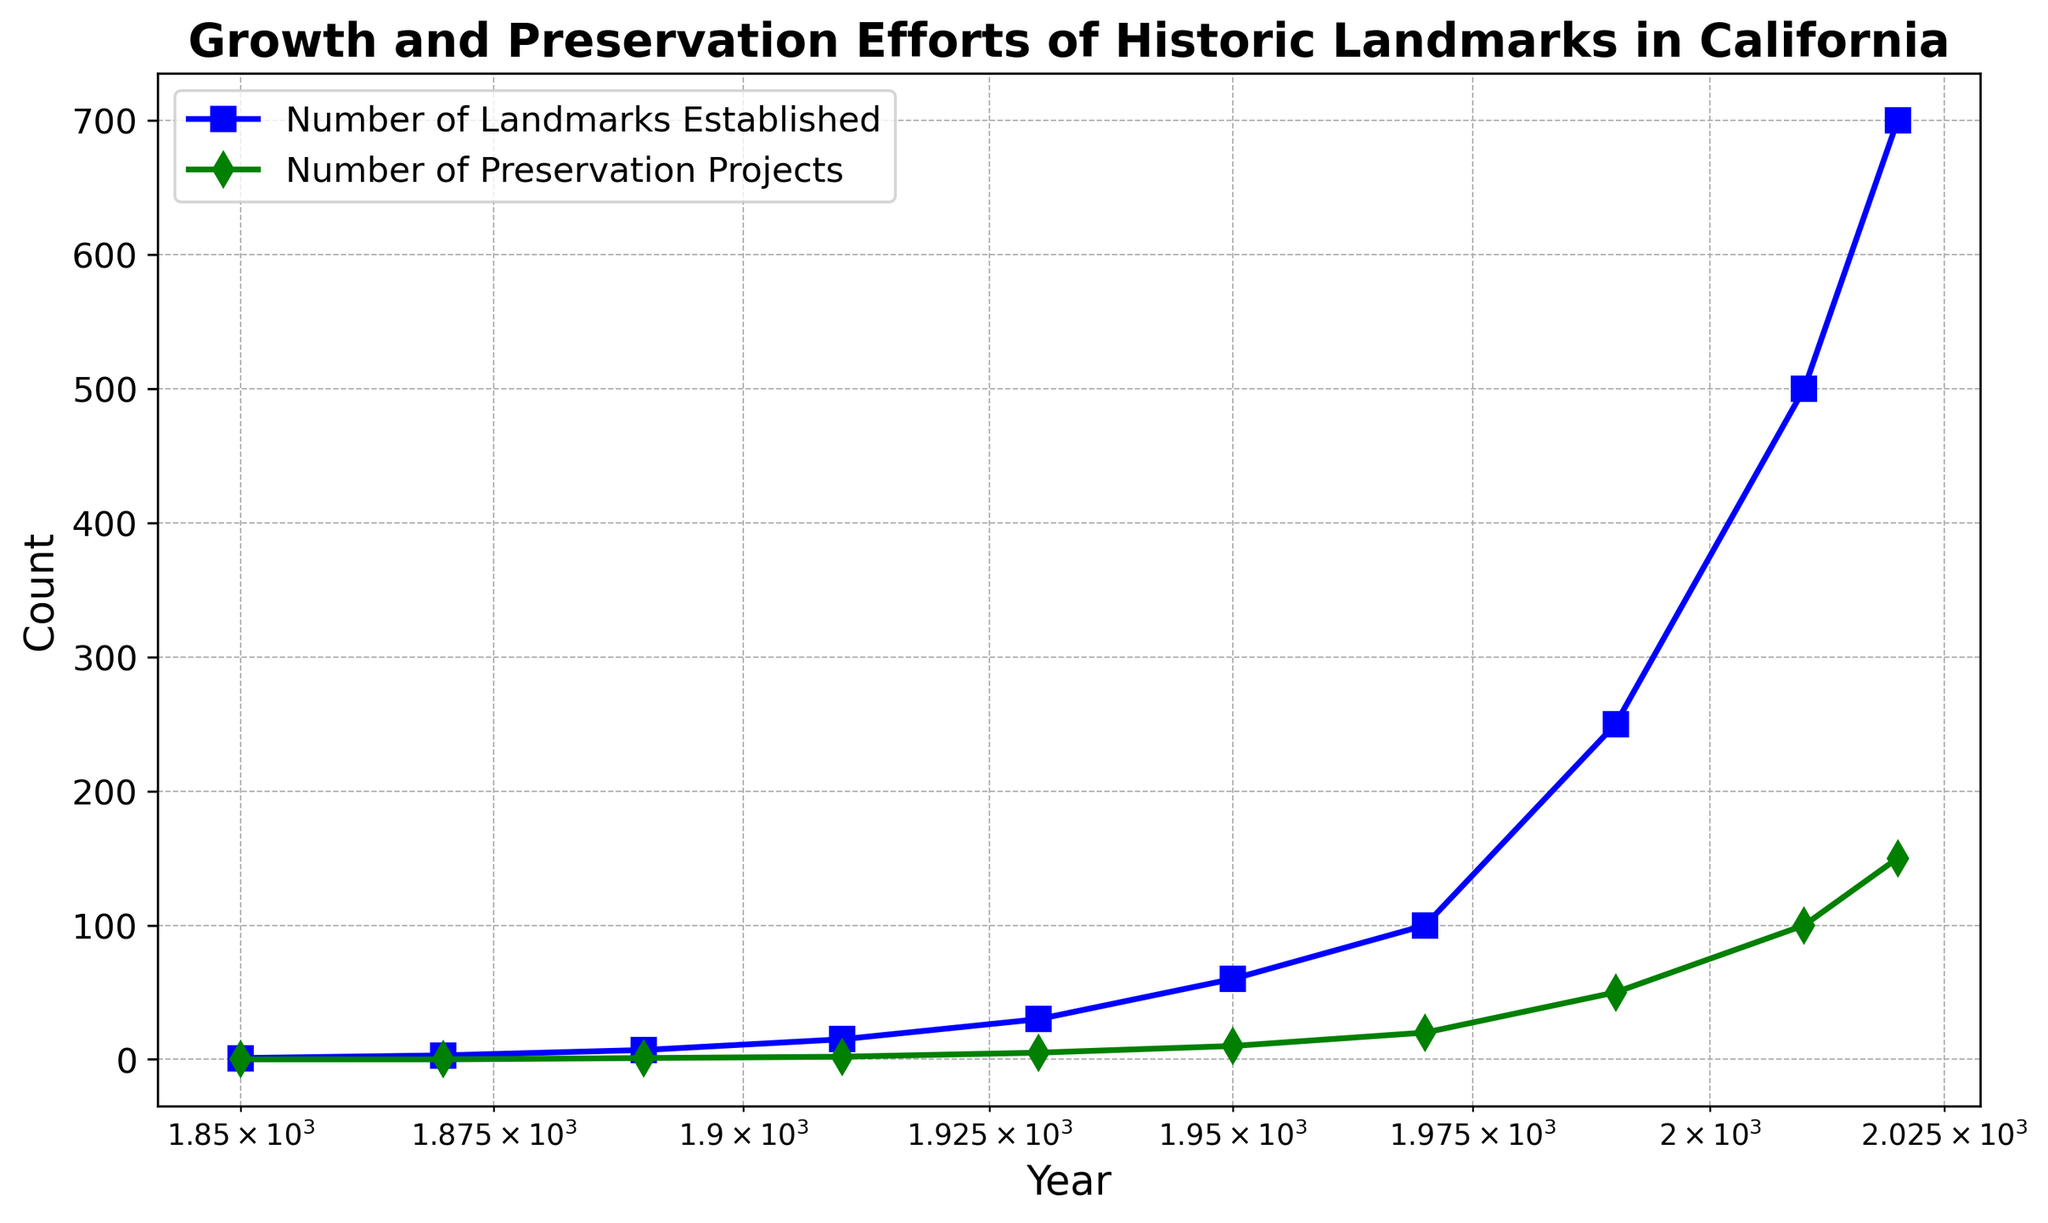What is the overall trend in the number of landmarks established from 1850 to 2020? The plot shows a consistent upward trend in the number of landmarks established over time, with a significant increase starting around 1930. By 2020, the number has reached 700.
Answer: Upward trend How many landmarks were established in 1970, and how many preservation projects were undertaken in the same year? The plot shows that in 1970, there were 100 landmarks established and 20 preservation projects undertaken.
Answer: 100 landmarks, 20 preservation projects How has the number of preservation projects changed from 1890 to 2020? The plot indicates a steady increase in preservation projects, starting from 1 project in 1890 to 150 projects in 2020.
Answer: Steady increase By how much did the number of preservation projects exceed the number of landmarks established in 2020? In 2020, there were 700 landmarks established and 150 preservation projects. The preservation projects did not exceed the landmarks, rather there were 550 fewer preservation projects compared to the landmarks.
Answer: 550 fewer Between which decades was the steepest growth in the number of landmarks established observed? The steepest growth appears to be between 1970 and 1990 where the number of landmarks increased from 100 to 250.
Answer: 1970 to 1990 Compare the number of landmarks established and preservation projects in 1950. Which was higher and by how much? In 1950, there were 60 landmarks established and 10 preservation projects. The number of landmarks established was higher by 50.
Answer: Landmarks higher by 50 What was the approximate ratio of preservation projects to landmarks established in 2010? In 2010, there were 500 landmarks established and 100 preservation projects. The ratio of preservation projects to landmarks established is 100/500 or 1:5.
Answer: 1:5 Which period saw a doubling in the number of landmarks established from approximately 250 to 500? The doubling in the number of landmarks from 250 to 500 occurred between 1990 and 2010.
Answer: 1990 to 2010 Visually, how can you distinguish between the lines representing landmarks established and preservation projects on the graph? The line representing landmarks established is in blue with circle markers, while the line representing preservation projects is in green with square markers.
Answer: Blue line with circles, Green line with squares Calculate the average number of preservation projects per decade from 1850 to 2020. To find the average number of preservation projects per decade: Sum of projects = 0+0+1+2+5+10+20+50+100+150 = 338; Number of decades = 10. Average = 338/10 = 33.8.
Answer: 33.8 